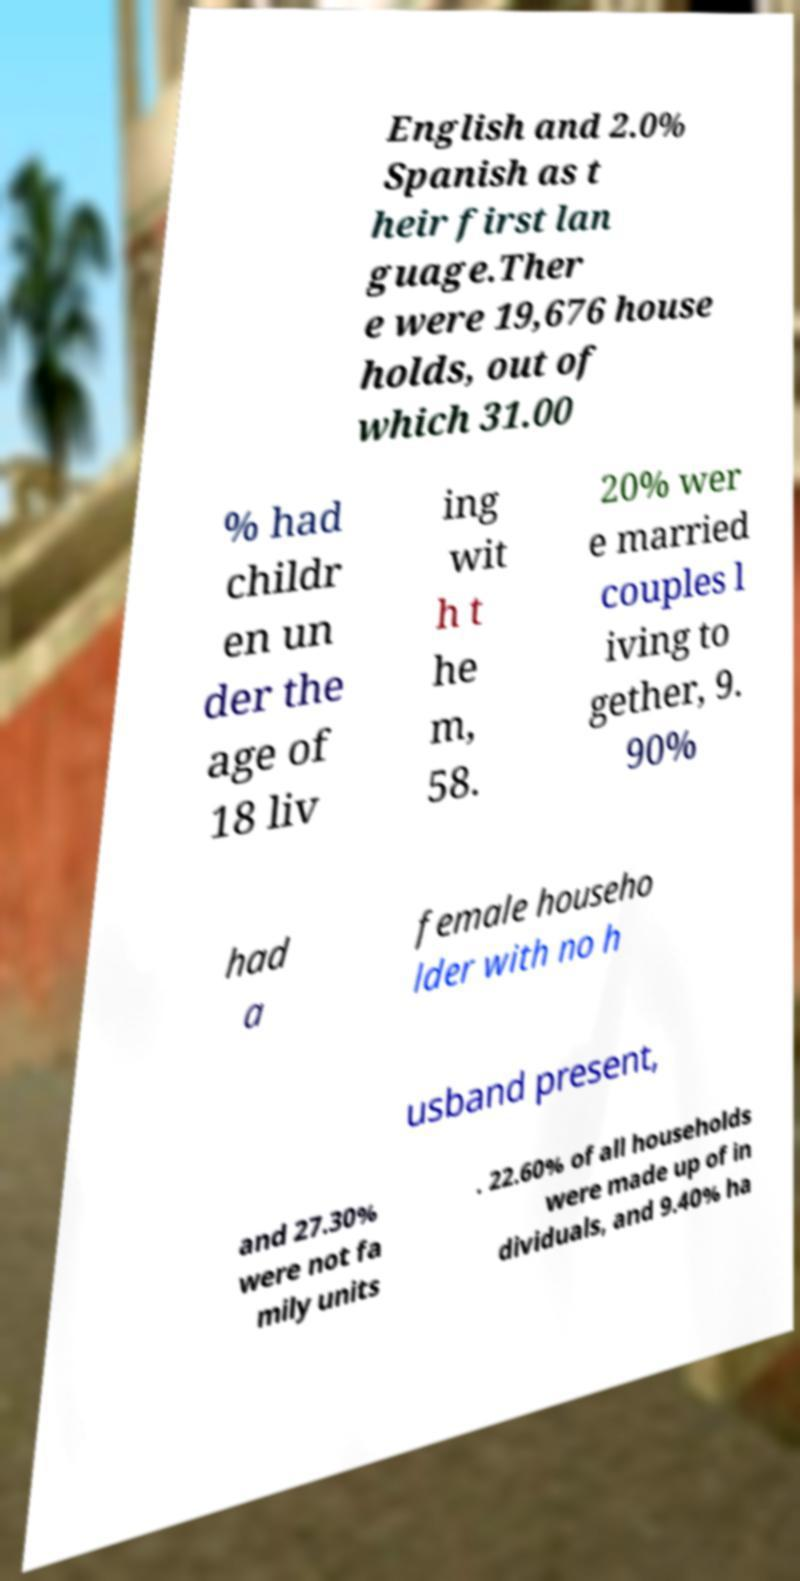What messages or text are displayed in this image? I need them in a readable, typed format. English and 2.0% Spanish as t heir first lan guage.Ther e were 19,676 house holds, out of which 31.00 % had childr en un der the age of 18 liv ing wit h t he m, 58. 20% wer e married couples l iving to gether, 9. 90% had a female househo lder with no h usband present, and 27.30% were not fa mily units . 22.60% of all households were made up of in dividuals, and 9.40% ha 